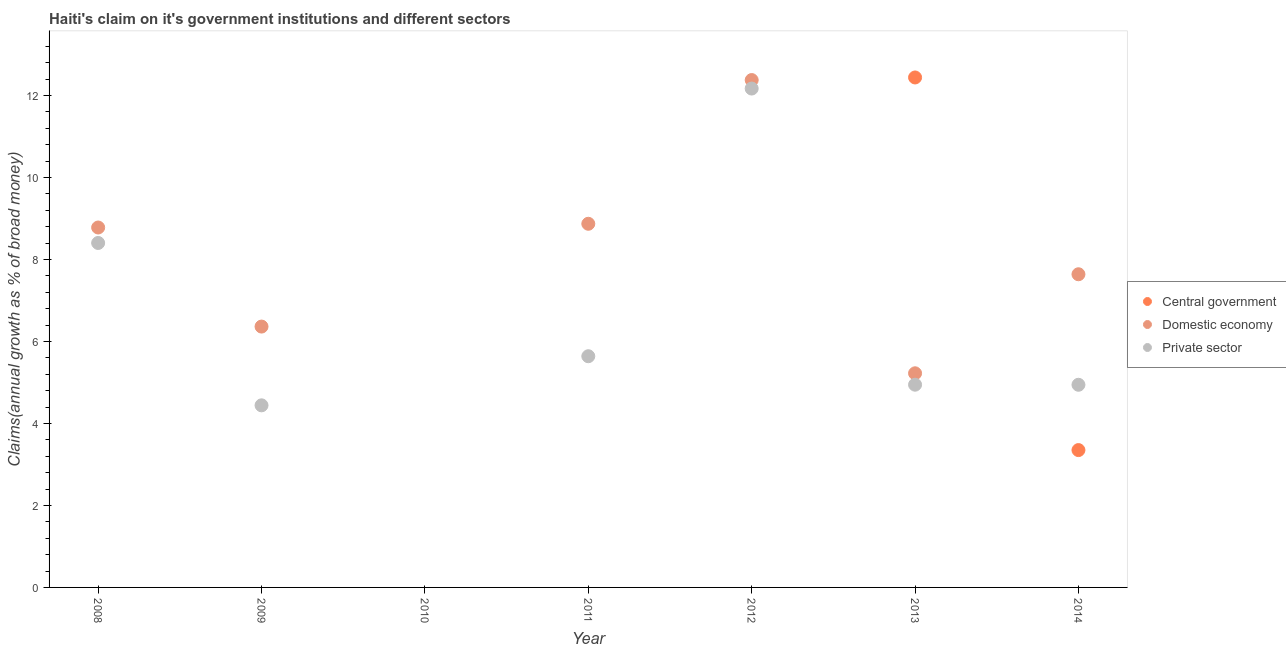Is the number of dotlines equal to the number of legend labels?
Keep it short and to the point. No. What is the percentage of claim on the domestic economy in 2009?
Provide a short and direct response. 6.36. Across all years, what is the maximum percentage of claim on the private sector?
Ensure brevity in your answer.  12.17. What is the total percentage of claim on the domestic economy in the graph?
Make the answer very short. 49.24. What is the difference between the percentage of claim on the private sector in 2008 and that in 2011?
Make the answer very short. 2.76. What is the difference between the percentage of claim on the private sector in 2013 and the percentage of claim on the central government in 2008?
Give a very brief answer. 4.94. What is the average percentage of claim on the central government per year?
Keep it short and to the point. 2.26. In the year 2014, what is the difference between the percentage of claim on the private sector and percentage of claim on the central government?
Make the answer very short. 1.59. In how many years, is the percentage of claim on the private sector greater than 2.8 %?
Offer a very short reply. 6. What is the ratio of the percentage of claim on the domestic economy in 2009 to that in 2012?
Give a very brief answer. 0.51. What is the difference between the highest and the second highest percentage of claim on the domestic economy?
Your answer should be very brief. 3.51. What is the difference between the highest and the lowest percentage of claim on the domestic economy?
Keep it short and to the point. 12.37. Is the sum of the percentage of claim on the domestic economy in 2012 and 2014 greater than the maximum percentage of claim on the private sector across all years?
Your response must be concise. Yes. Is it the case that in every year, the sum of the percentage of claim on the central government and percentage of claim on the domestic economy is greater than the percentage of claim on the private sector?
Provide a short and direct response. No. Does the percentage of claim on the domestic economy monotonically increase over the years?
Offer a very short reply. No. Is the percentage of claim on the central government strictly less than the percentage of claim on the domestic economy over the years?
Your answer should be very brief. No. How many dotlines are there?
Offer a terse response. 3. What is the difference between two consecutive major ticks on the Y-axis?
Make the answer very short. 2. Are the values on the major ticks of Y-axis written in scientific E-notation?
Your answer should be very brief. No. Does the graph contain grids?
Offer a very short reply. No. Where does the legend appear in the graph?
Offer a very short reply. Center right. How are the legend labels stacked?
Provide a succinct answer. Vertical. What is the title of the graph?
Your answer should be compact. Haiti's claim on it's government institutions and different sectors. What is the label or title of the X-axis?
Provide a short and direct response. Year. What is the label or title of the Y-axis?
Provide a succinct answer. Claims(annual growth as % of broad money). What is the Claims(annual growth as % of broad money) in Central government in 2008?
Make the answer very short. 0. What is the Claims(annual growth as % of broad money) of Domestic economy in 2008?
Offer a very short reply. 8.78. What is the Claims(annual growth as % of broad money) in Private sector in 2008?
Give a very brief answer. 8.4. What is the Claims(annual growth as % of broad money) of Central government in 2009?
Your answer should be compact. 0. What is the Claims(annual growth as % of broad money) in Domestic economy in 2009?
Provide a short and direct response. 6.36. What is the Claims(annual growth as % of broad money) in Private sector in 2009?
Ensure brevity in your answer.  4.44. What is the Claims(annual growth as % of broad money) of Private sector in 2010?
Make the answer very short. 0. What is the Claims(annual growth as % of broad money) of Domestic economy in 2011?
Your answer should be very brief. 8.87. What is the Claims(annual growth as % of broad money) of Private sector in 2011?
Provide a short and direct response. 5.64. What is the Claims(annual growth as % of broad money) in Central government in 2012?
Make the answer very short. 0. What is the Claims(annual growth as % of broad money) of Domestic economy in 2012?
Your answer should be very brief. 12.37. What is the Claims(annual growth as % of broad money) of Private sector in 2012?
Make the answer very short. 12.17. What is the Claims(annual growth as % of broad money) in Central government in 2013?
Keep it short and to the point. 12.44. What is the Claims(annual growth as % of broad money) of Domestic economy in 2013?
Give a very brief answer. 5.22. What is the Claims(annual growth as % of broad money) in Private sector in 2013?
Your response must be concise. 4.94. What is the Claims(annual growth as % of broad money) in Central government in 2014?
Offer a terse response. 3.35. What is the Claims(annual growth as % of broad money) of Domestic economy in 2014?
Give a very brief answer. 7.64. What is the Claims(annual growth as % of broad money) of Private sector in 2014?
Ensure brevity in your answer.  4.94. Across all years, what is the maximum Claims(annual growth as % of broad money) in Central government?
Offer a terse response. 12.44. Across all years, what is the maximum Claims(annual growth as % of broad money) of Domestic economy?
Ensure brevity in your answer.  12.37. Across all years, what is the maximum Claims(annual growth as % of broad money) of Private sector?
Your answer should be very brief. 12.17. Across all years, what is the minimum Claims(annual growth as % of broad money) of Central government?
Ensure brevity in your answer.  0. What is the total Claims(annual growth as % of broad money) of Central government in the graph?
Your answer should be very brief. 15.79. What is the total Claims(annual growth as % of broad money) of Domestic economy in the graph?
Offer a very short reply. 49.24. What is the total Claims(annual growth as % of broad money) of Private sector in the graph?
Your response must be concise. 40.53. What is the difference between the Claims(annual growth as % of broad money) in Domestic economy in 2008 and that in 2009?
Your answer should be compact. 2.42. What is the difference between the Claims(annual growth as % of broad money) in Private sector in 2008 and that in 2009?
Offer a very short reply. 3.96. What is the difference between the Claims(annual growth as % of broad money) in Domestic economy in 2008 and that in 2011?
Provide a short and direct response. -0.09. What is the difference between the Claims(annual growth as % of broad money) of Private sector in 2008 and that in 2011?
Make the answer very short. 2.76. What is the difference between the Claims(annual growth as % of broad money) in Domestic economy in 2008 and that in 2012?
Make the answer very short. -3.6. What is the difference between the Claims(annual growth as % of broad money) in Private sector in 2008 and that in 2012?
Keep it short and to the point. -3.77. What is the difference between the Claims(annual growth as % of broad money) in Domestic economy in 2008 and that in 2013?
Give a very brief answer. 3.56. What is the difference between the Claims(annual growth as % of broad money) of Private sector in 2008 and that in 2013?
Keep it short and to the point. 3.46. What is the difference between the Claims(annual growth as % of broad money) in Domestic economy in 2008 and that in 2014?
Your answer should be compact. 1.14. What is the difference between the Claims(annual growth as % of broad money) of Private sector in 2008 and that in 2014?
Offer a very short reply. 3.46. What is the difference between the Claims(annual growth as % of broad money) of Domestic economy in 2009 and that in 2011?
Make the answer very short. -2.51. What is the difference between the Claims(annual growth as % of broad money) in Private sector in 2009 and that in 2011?
Your answer should be very brief. -1.2. What is the difference between the Claims(annual growth as % of broad money) in Domestic economy in 2009 and that in 2012?
Offer a terse response. -6.01. What is the difference between the Claims(annual growth as % of broad money) in Private sector in 2009 and that in 2012?
Your answer should be very brief. -7.73. What is the difference between the Claims(annual growth as % of broad money) of Domestic economy in 2009 and that in 2013?
Keep it short and to the point. 1.14. What is the difference between the Claims(annual growth as % of broad money) of Private sector in 2009 and that in 2013?
Keep it short and to the point. -0.5. What is the difference between the Claims(annual growth as % of broad money) in Domestic economy in 2009 and that in 2014?
Your response must be concise. -1.28. What is the difference between the Claims(annual growth as % of broad money) of Private sector in 2009 and that in 2014?
Your answer should be compact. -0.5. What is the difference between the Claims(annual growth as % of broad money) of Domestic economy in 2011 and that in 2012?
Offer a terse response. -3.51. What is the difference between the Claims(annual growth as % of broad money) of Private sector in 2011 and that in 2012?
Your response must be concise. -6.53. What is the difference between the Claims(annual growth as % of broad money) in Domestic economy in 2011 and that in 2013?
Your answer should be very brief. 3.65. What is the difference between the Claims(annual growth as % of broad money) of Private sector in 2011 and that in 2013?
Ensure brevity in your answer.  0.69. What is the difference between the Claims(annual growth as % of broad money) in Domestic economy in 2011 and that in 2014?
Your answer should be compact. 1.23. What is the difference between the Claims(annual growth as % of broad money) of Private sector in 2011 and that in 2014?
Give a very brief answer. 0.7. What is the difference between the Claims(annual growth as % of broad money) in Domestic economy in 2012 and that in 2013?
Your response must be concise. 7.15. What is the difference between the Claims(annual growth as % of broad money) in Private sector in 2012 and that in 2013?
Offer a terse response. 7.22. What is the difference between the Claims(annual growth as % of broad money) of Domestic economy in 2012 and that in 2014?
Ensure brevity in your answer.  4.74. What is the difference between the Claims(annual growth as % of broad money) of Private sector in 2012 and that in 2014?
Give a very brief answer. 7.22. What is the difference between the Claims(annual growth as % of broad money) of Central government in 2013 and that in 2014?
Ensure brevity in your answer.  9.09. What is the difference between the Claims(annual growth as % of broad money) of Domestic economy in 2013 and that in 2014?
Offer a terse response. -2.42. What is the difference between the Claims(annual growth as % of broad money) of Private sector in 2013 and that in 2014?
Ensure brevity in your answer.  0. What is the difference between the Claims(annual growth as % of broad money) of Domestic economy in 2008 and the Claims(annual growth as % of broad money) of Private sector in 2009?
Ensure brevity in your answer.  4.34. What is the difference between the Claims(annual growth as % of broad money) in Domestic economy in 2008 and the Claims(annual growth as % of broad money) in Private sector in 2011?
Offer a very short reply. 3.14. What is the difference between the Claims(annual growth as % of broad money) of Domestic economy in 2008 and the Claims(annual growth as % of broad money) of Private sector in 2012?
Provide a succinct answer. -3.39. What is the difference between the Claims(annual growth as % of broad money) in Domestic economy in 2008 and the Claims(annual growth as % of broad money) in Private sector in 2013?
Your response must be concise. 3.83. What is the difference between the Claims(annual growth as % of broad money) of Domestic economy in 2008 and the Claims(annual growth as % of broad money) of Private sector in 2014?
Your answer should be compact. 3.84. What is the difference between the Claims(annual growth as % of broad money) of Domestic economy in 2009 and the Claims(annual growth as % of broad money) of Private sector in 2011?
Keep it short and to the point. 0.72. What is the difference between the Claims(annual growth as % of broad money) in Domestic economy in 2009 and the Claims(annual growth as % of broad money) in Private sector in 2012?
Your answer should be compact. -5.81. What is the difference between the Claims(annual growth as % of broad money) of Domestic economy in 2009 and the Claims(annual growth as % of broad money) of Private sector in 2013?
Make the answer very short. 1.42. What is the difference between the Claims(annual growth as % of broad money) in Domestic economy in 2009 and the Claims(annual growth as % of broad money) in Private sector in 2014?
Your answer should be very brief. 1.42. What is the difference between the Claims(annual growth as % of broad money) of Domestic economy in 2011 and the Claims(annual growth as % of broad money) of Private sector in 2012?
Keep it short and to the point. -3.3. What is the difference between the Claims(annual growth as % of broad money) in Domestic economy in 2011 and the Claims(annual growth as % of broad money) in Private sector in 2013?
Your answer should be compact. 3.92. What is the difference between the Claims(annual growth as % of broad money) in Domestic economy in 2011 and the Claims(annual growth as % of broad money) in Private sector in 2014?
Give a very brief answer. 3.93. What is the difference between the Claims(annual growth as % of broad money) in Domestic economy in 2012 and the Claims(annual growth as % of broad money) in Private sector in 2013?
Offer a terse response. 7.43. What is the difference between the Claims(annual growth as % of broad money) of Domestic economy in 2012 and the Claims(annual growth as % of broad money) of Private sector in 2014?
Your answer should be compact. 7.43. What is the difference between the Claims(annual growth as % of broad money) in Central government in 2013 and the Claims(annual growth as % of broad money) in Domestic economy in 2014?
Give a very brief answer. 4.8. What is the difference between the Claims(annual growth as % of broad money) in Central government in 2013 and the Claims(annual growth as % of broad money) in Private sector in 2014?
Your answer should be very brief. 7.49. What is the difference between the Claims(annual growth as % of broad money) of Domestic economy in 2013 and the Claims(annual growth as % of broad money) of Private sector in 2014?
Make the answer very short. 0.28. What is the average Claims(annual growth as % of broad money) of Central government per year?
Your response must be concise. 2.26. What is the average Claims(annual growth as % of broad money) in Domestic economy per year?
Your answer should be very brief. 7.03. What is the average Claims(annual growth as % of broad money) in Private sector per year?
Ensure brevity in your answer.  5.79. In the year 2008, what is the difference between the Claims(annual growth as % of broad money) of Domestic economy and Claims(annual growth as % of broad money) of Private sector?
Provide a short and direct response. 0.38. In the year 2009, what is the difference between the Claims(annual growth as % of broad money) of Domestic economy and Claims(annual growth as % of broad money) of Private sector?
Your answer should be very brief. 1.92. In the year 2011, what is the difference between the Claims(annual growth as % of broad money) of Domestic economy and Claims(annual growth as % of broad money) of Private sector?
Provide a short and direct response. 3.23. In the year 2012, what is the difference between the Claims(annual growth as % of broad money) in Domestic economy and Claims(annual growth as % of broad money) in Private sector?
Your answer should be very brief. 0.21. In the year 2013, what is the difference between the Claims(annual growth as % of broad money) in Central government and Claims(annual growth as % of broad money) in Domestic economy?
Offer a very short reply. 7.21. In the year 2013, what is the difference between the Claims(annual growth as % of broad money) of Central government and Claims(annual growth as % of broad money) of Private sector?
Your answer should be compact. 7.49. In the year 2013, what is the difference between the Claims(annual growth as % of broad money) of Domestic economy and Claims(annual growth as % of broad money) of Private sector?
Offer a terse response. 0.28. In the year 2014, what is the difference between the Claims(annual growth as % of broad money) of Central government and Claims(annual growth as % of broad money) of Domestic economy?
Your answer should be compact. -4.29. In the year 2014, what is the difference between the Claims(annual growth as % of broad money) in Central government and Claims(annual growth as % of broad money) in Private sector?
Keep it short and to the point. -1.59. In the year 2014, what is the difference between the Claims(annual growth as % of broad money) in Domestic economy and Claims(annual growth as % of broad money) in Private sector?
Your answer should be compact. 2.7. What is the ratio of the Claims(annual growth as % of broad money) of Domestic economy in 2008 to that in 2009?
Offer a very short reply. 1.38. What is the ratio of the Claims(annual growth as % of broad money) of Private sector in 2008 to that in 2009?
Your answer should be very brief. 1.89. What is the ratio of the Claims(annual growth as % of broad money) in Domestic economy in 2008 to that in 2011?
Offer a terse response. 0.99. What is the ratio of the Claims(annual growth as % of broad money) in Private sector in 2008 to that in 2011?
Offer a terse response. 1.49. What is the ratio of the Claims(annual growth as % of broad money) in Domestic economy in 2008 to that in 2012?
Ensure brevity in your answer.  0.71. What is the ratio of the Claims(annual growth as % of broad money) in Private sector in 2008 to that in 2012?
Provide a succinct answer. 0.69. What is the ratio of the Claims(annual growth as % of broad money) in Domestic economy in 2008 to that in 2013?
Offer a terse response. 1.68. What is the ratio of the Claims(annual growth as % of broad money) of Private sector in 2008 to that in 2013?
Your response must be concise. 1.7. What is the ratio of the Claims(annual growth as % of broad money) in Domestic economy in 2008 to that in 2014?
Provide a succinct answer. 1.15. What is the ratio of the Claims(annual growth as % of broad money) of Private sector in 2008 to that in 2014?
Your answer should be compact. 1.7. What is the ratio of the Claims(annual growth as % of broad money) in Domestic economy in 2009 to that in 2011?
Offer a very short reply. 0.72. What is the ratio of the Claims(annual growth as % of broad money) in Private sector in 2009 to that in 2011?
Offer a very short reply. 0.79. What is the ratio of the Claims(annual growth as % of broad money) of Domestic economy in 2009 to that in 2012?
Your answer should be compact. 0.51. What is the ratio of the Claims(annual growth as % of broad money) of Private sector in 2009 to that in 2012?
Provide a short and direct response. 0.36. What is the ratio of the Claims(annual growth as % of broad money) in Domestic economy in 2009 to that in 2013?
Provide a succinct answer. 1.22. What is the ratio of the Claims(annual growth as % of broad money) in Private sector in 2009 to that in 2013?
Your response must be concise. 0.9. What is the ratio of the Claims(annual growth as % of broad money) in Domestic economy in 2009 to that in 2014?
Make the answer very short. 0.83. What is the ratio of the Claims(annual growth as % of broad money) of Private sector in 2009 to that in 2014?
Your answer should be very brief. 0.9. What is the ratio of the Claims(annual growth as % of broad money) of Domestic economy in 2011 to that in 2012?
Your answer should be very brief. 0.72. What is the ratio of the Claims(annual growth as % of broad money) in Private sector in 2011 to that in 2012?
Offer a terse response. 0.46. What is the ratio of the Claims(annual growth as % of broad money) in Domestic economy in 2011 to that in 2013?
Offer a terse response. 1.7. What is the ratio of the Claims(annual growth as % of broad money) of Private sector in 2011 to that in 2013?
Give a very brief answer. 1.14. What is the ratio of the Claims(annual growth as % of broad money) in Domestic economy in 2011 to that in 2014?
Your answer should be very brief. 1.16. What is the ratio of the Claims(annual growth as % of broad money) of Private sector in 2011 to that in 2014?
Ensure brevity in your answer.  1.14. What is the ratio of the Claims(annual growth as % of broad money) in Domestic economy in 2012 to that in 2013?
Give a very brief answer. 2.37. What is the ratio of the Claims(annual growth as % of broad money) in Private sector in 2012 to that in 2013?
Offer a terse response. 2.46. What is the ratio of the Claims(annual growth as % of broad money) of Domestic economy in 2012 to that in 2014?
Your response must be concise. 1.62. What is the ratio of the Claims(annual growth as % of broad money) of Private sector in 2012 to that in 2014?
Make the answer very short. 2.46. What is the ratio of the Claims(annual growth as % of broad money) of Central government in 2013 to that in 2014?
Provide a short and direct response. 3.71. What is the ratio of the Claims(annual growth as % of broad money) in Domestic economy in 2013 to that in 2014?
Provide a short and direct response. 0.68. What is the ratio of the Claims(annual growth as % of broad money) of Private sector in 2013 to that in 2014?
Your response must be concise. 1. What is the difference between the highest and the second highest Claims(annual growth as % of broad money) in Domestic economy?
Offer a terse response. 3.51. What is the difference between the highest and the second highest Claims(annual growth as % of broad money) of Private sector?
Give a very brief answer. 3.77. What is the difference between the highest and the lowest Claims(annual growth as % of broad money) in Central government?
Your answer should be compact. 12.44. What is the difference between the highest and the lowest Claims(annual growth as % of broad money) of Domestic economy?
Give a very brief answer. 12.37. What is the difference between the highest and the lowest Claims(annual growth as % of broad money) of Private sector?
Give a very brief answer. 12.17. 